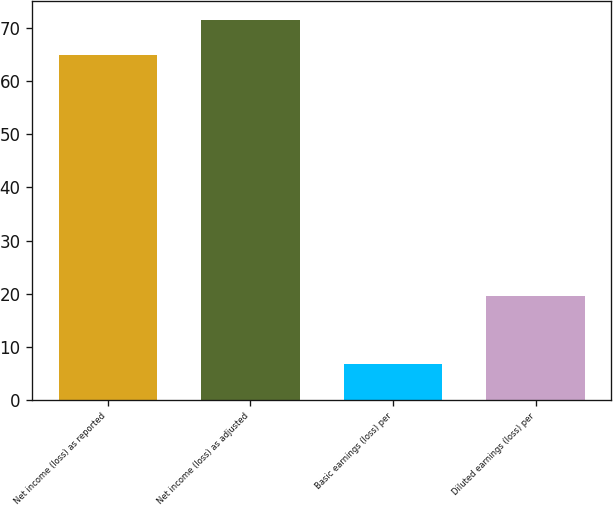<chart> <loc_0><loc_0><loc_500><loc_500><bar_chart><fcel>Net income (loss) as reported<fcel>Net income (loss) as adjusted<fcel>Basic earnings (loss) per<fcel>Diluted earnings (loss) per<nl><fcel>65<fcel>71.48<fcel>6.66<fcel>19.62<nl></chart> 